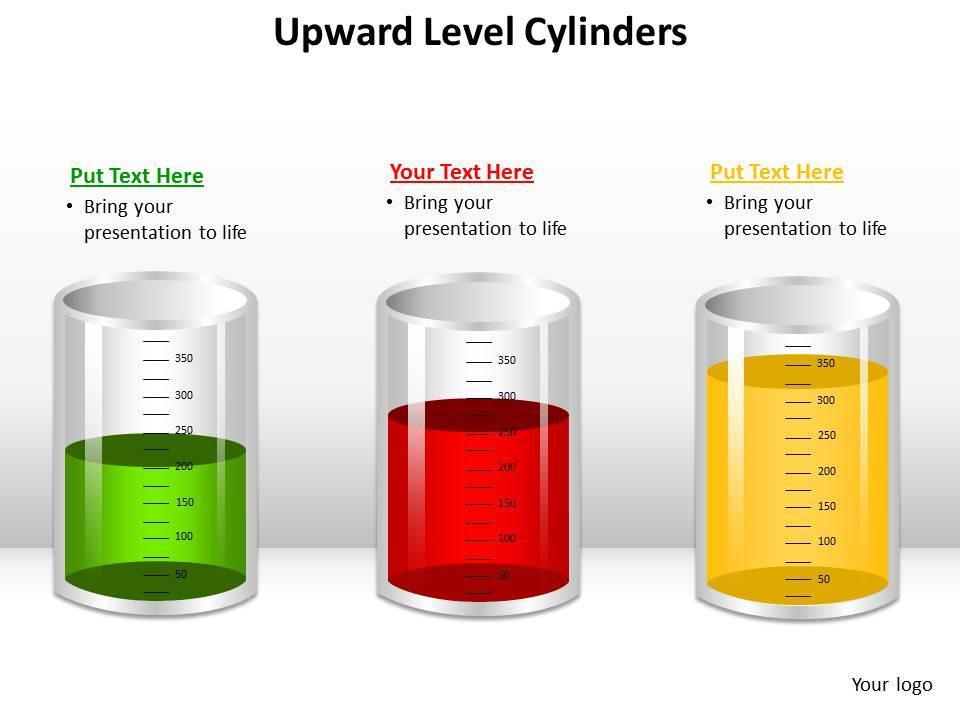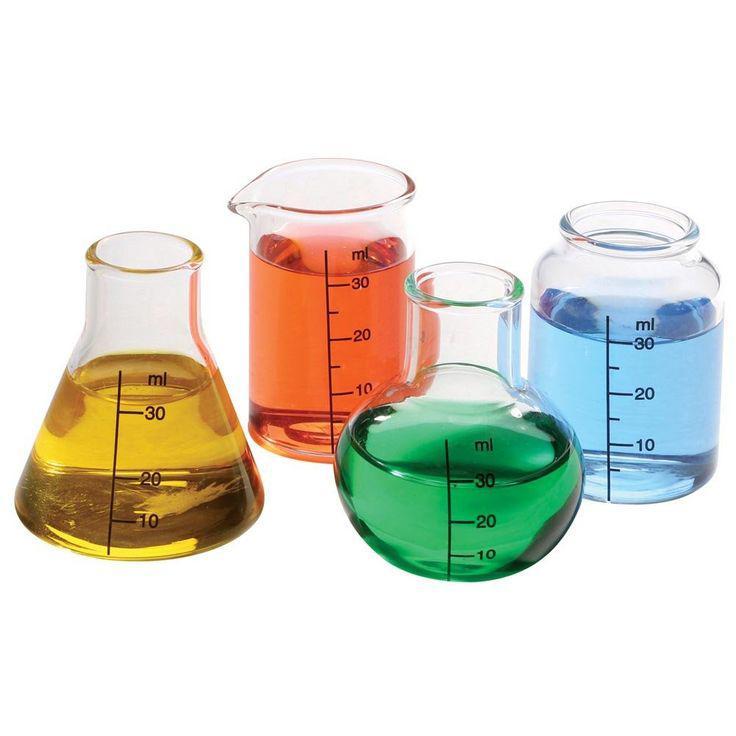The first image is the image on the left, the second image is the image on the right. Evaluate the accuracy of this statement regarding the images: "The right image contains exactly four flasks.". Is it true? Answer yes or no. Yes. The first image is the image on the left, the second image is the image on the right. Considering the images on both sides, is "All glass vessels contain a non-clear liquid, and one set of beakers shares the same shape." valid? Answer yes or no. Yes. 